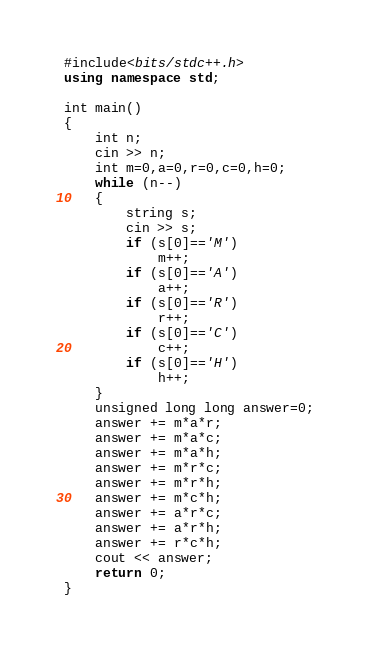<code> <loc_0><loc_0><loc_500><loc_500><_C++_>#include<bits/stdc++.h>
using namespace std;

int main()
{
	int n;
	cin >> n;
	int m=0,a=0,r=0,c=0,h=0;
	while (n--)
	{
		string s;
		cin >> s;
		if (s[0]=='M')
			m++;
		if (s[0]=='A')
			a++;
		if (s[0]=='R')
			r++;
		if (s[0]=='C')
			c++;
		if (s[0]=='H')
			h++;
	}
	unsigned long long answer=0;
	answer += m*a*r;
	answer += m*a*c;
	answer += m*a*h;
	answer += m*r*c;
	answer += m*r*h;
	answer += m*c*h;
	answer += a*r*c;
	answer += a*r*h;
	answer += r*c*h;
	cout << answer;
	return 0;
}
</code> 